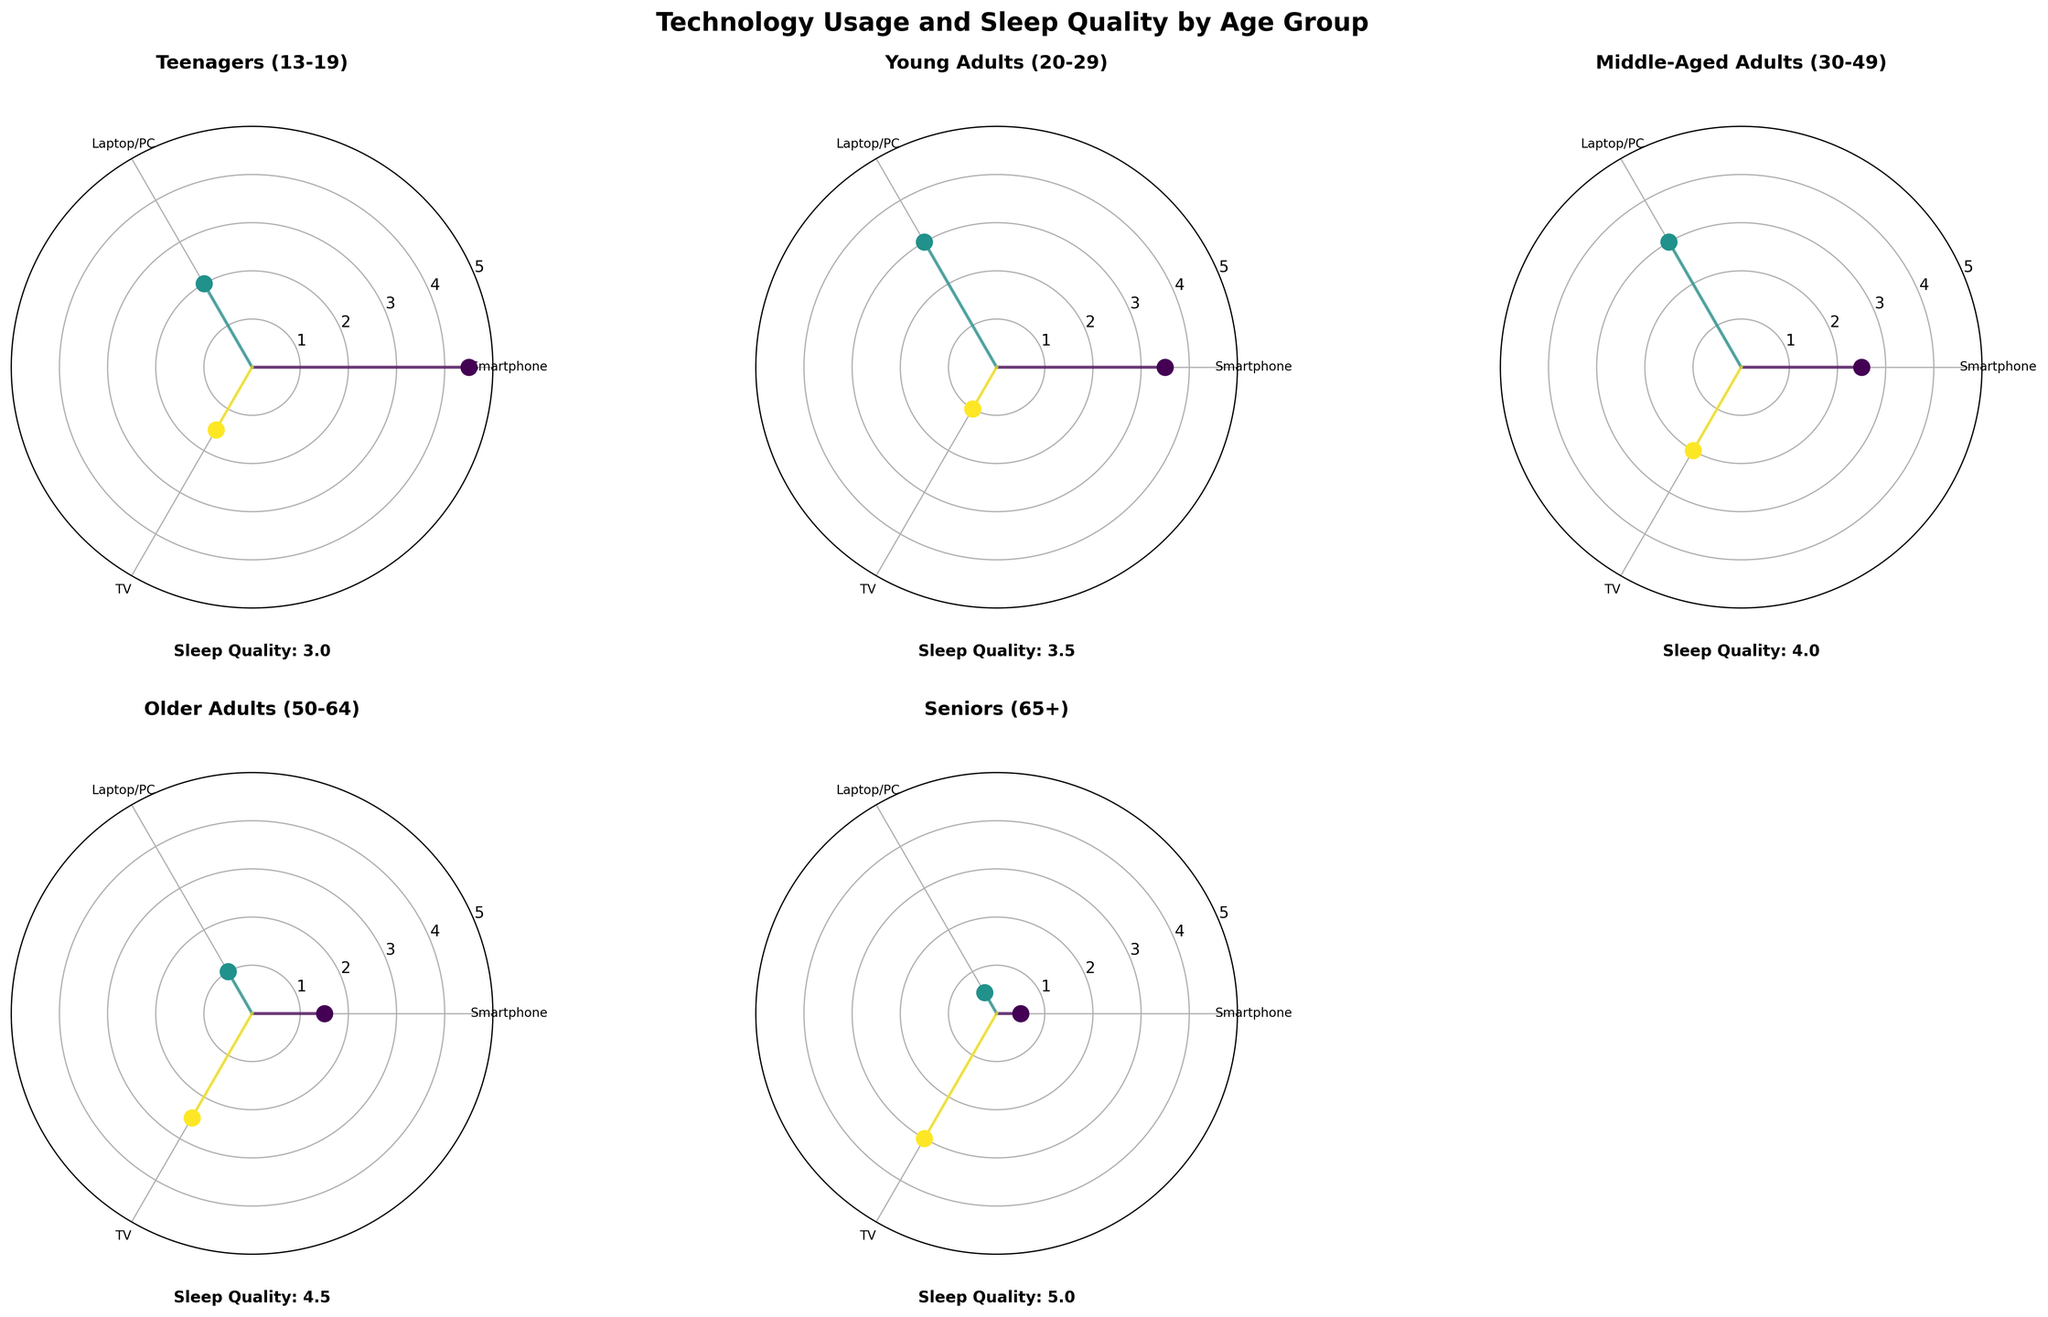What's the average sleep quality of middle-aged adults? The plot for middle-aged adults is labeled with a sleep quality of 4. The value is indicated directly on the plot.
Answer: 4 Which age group has the highest smartphone usage? By observing the data points on each subplot, the teenagers group shows the highest point for smartphone usage, indicated by a marker at 4.5 hours.
Answer: Teenagers How does TV usage compare between older adults and seniors (65+)? The plot for older adults shows TV usage at 2.5 hours, whereas for seniors (65+), it is at 3.0 hours. Seniors have higher TV usage.
Answer: Seniors have higher TV usage Which age group goes to bed the earliest? Observing the individual subplots, the “Seniors (65+)” plot shows a bedtime of 21:30, which is the earliest among all the age groups.
Answer: Seniors What's the difference in laptop/PC usage between young adults (20-29) and middle-aged adults (30-49)? Young adults have a laptop/PC usage of 3.0 hours, while middle-aged adults also have 3.0 hours. The difference is 0 hours.
Answer: 0 hours What is the common average sleep quality for older adults (50-64) and seniors (65+)? Observing both subplots, older adults have a sleep quality of 4.5, and seniors have a sleep quality of 5. The common average is (4.5 + 5)/2 = 4.75.
Answer: 4.75 Which age group spends the least time using a smartphone? The subplot for seniors (65+) indicates they spend 0.5 hours on smartphones, which is the lowest among all age groups.
Answer: Seniors Is the average bedtime of young adults earlier or later than that of teenagers? The average bedtime for young adults is indicated as 23:00, and for teenagers as 23:30. Therefore, young adults go to bed earlier.
Answer: Young adults go to bed earlier How many technology types are presented in each subplot? Each subplot shows three different technology types: Smartphone, Laptop/PC, and TV.
Answer: 3 What is the wakeup time for middle-aged adults as presented in the plot? The subplot for middle-aged adults indicates their wakeup time as 06:00.
Answer: 06:00 